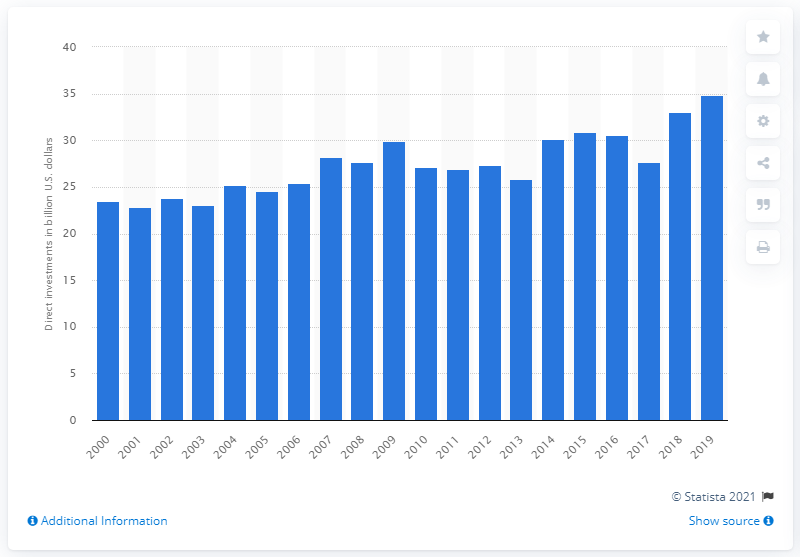Draw attention to some important aspects in this diagram. The value of the investments made in Italy in 2019 was 34.9 billion euros. 